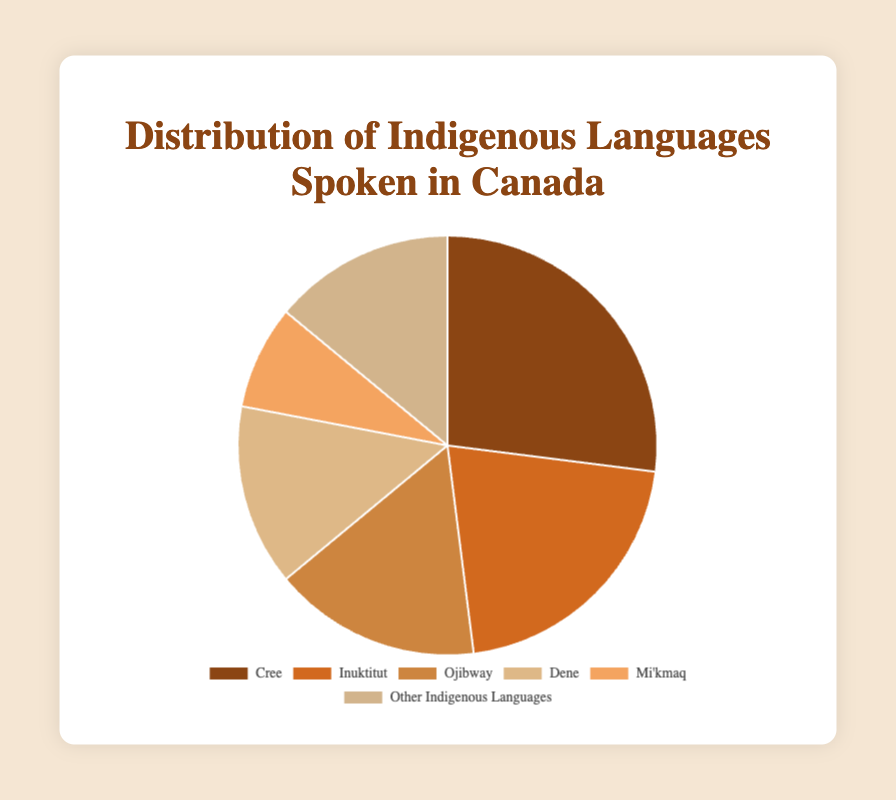Which Indigenous language is most widely spoken in Canada? The figure shows the distribution of Indigenous languages. The largest section of the pie chart represents Cree, with a percentage of 27%.
Answer: Cree Which two Indigenous languages together make up more than 40% of the languages spoken? By adding the percentages of the two largest sections: Cree (27%) and Inuktitut (21%), we get 27% + 21% = 48%, which is more than 40%.
Answer: Cree and Inuktitut Is Ojibway spoken by a smaller percentage of people compared to Dene? The pie chart indicates that Ojibway is 16%, whereas Dene is 14%. Ojibway is spoken by a larger percentage of people compared to Dene.
Answer: No What percentage of people speak either Dene or "Other Indigenous Languages"? By adding the percentages for Dene (14%) and Other Indigenous Languages (14%), the total is 14% + 14% = 28%.
Answer: 28% Which color in the pie chart represents the Ojibway language? Ojibway is represented by the third section of the pie chart, which corresponds to the color light brown.
Answer: Light brown How much more popular is Cree compared to Mi'kmaq? Cree has a percentage of 27% and Mi'kmaq has 8%. The difference is calculated as 27% - 8% = 19%.
Answer: 19% If you combined the percentages of Ojibway, Dene, and Mi'kmaq, would it be greater than the percentage of Cree? Adding the percentages of Ojibway (16%), Dene (14%), and Mi'kmaq (8%), the total is 16% + 14% + 8% = 38%. This is greater than Cree's 27%.
Answer: Yes How does the combined percentage of Inuktitut and Dene compare to that of Cree? Adding the percentages of Inuktitut (21%) and Dene (14%) gives 21% + 14% = 35%, which is greater than Cree's 27%.
Answer: Greater Which section of the pie chart is represented by the lightest color? The lightest section of the pie chart, visually, is most likely "Other Indigenous Languages," which is a light tan color.
Answer: Other Indigenous Languages What is the sum of the percentages for Inuktitut, Ojibway, and Mi'kmaq? Adding the percentages for Inuktitut (21%), Ojibway (16%), and Mi'kmaq (8%) gives 21% + 16% + 8% = 45%.
Answer: 45% 